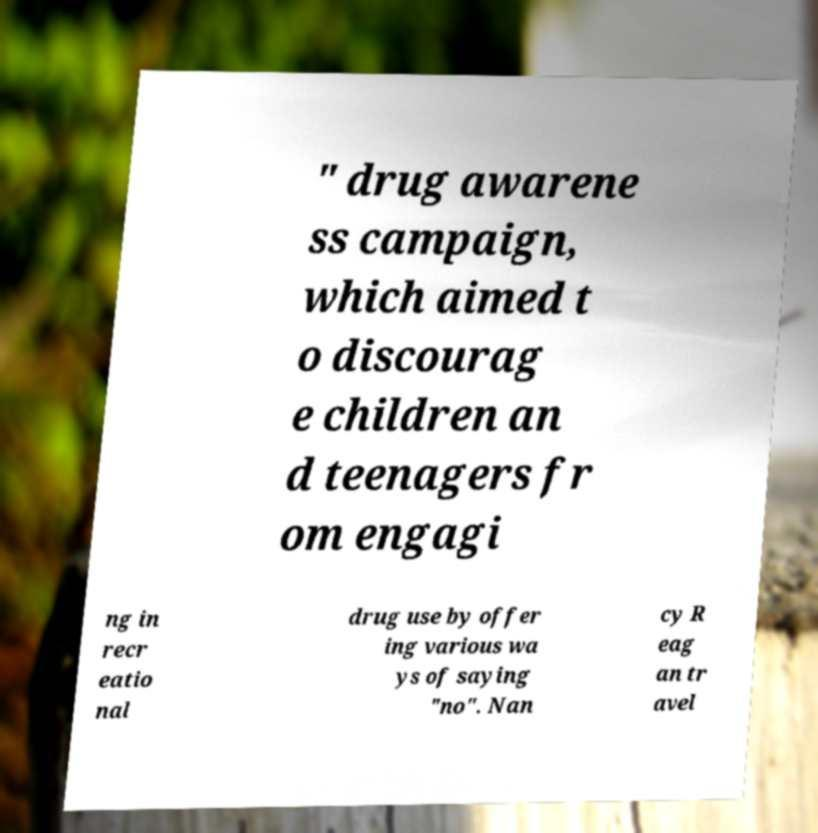Can you read and provide the text displayed in the image?This photo seems to have some interesting text. Can you extract and type it out for me? " drug awarene ss campaign, which aimed t o discourag e children an d teenagers fr om engagi ng in recr eatio nal drug use by offer ing various wa ys of saying "no". Nan cy R eag an tr avel 